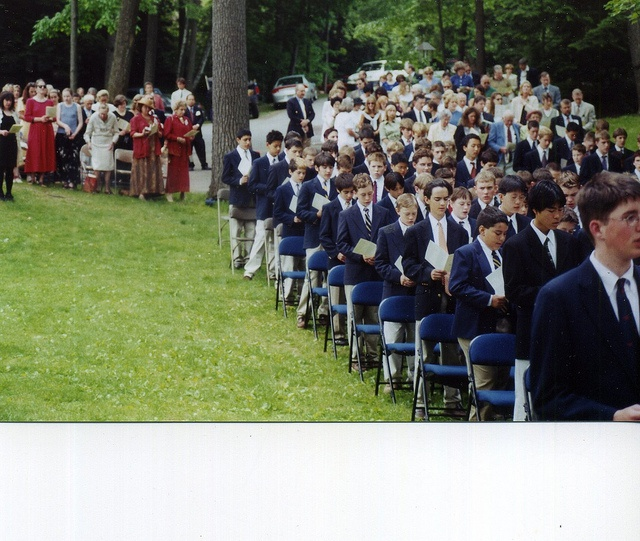Describe the objects in this image and their specific colors. I can see people in black, brown, gray, and darkgray tones, people in black, darkgray, and maroon tones, people in black, navy, and gray tones, people in black, navy, darkgray, and gray tones, and people in black, darkgray, gray, and navy tones in this image. 